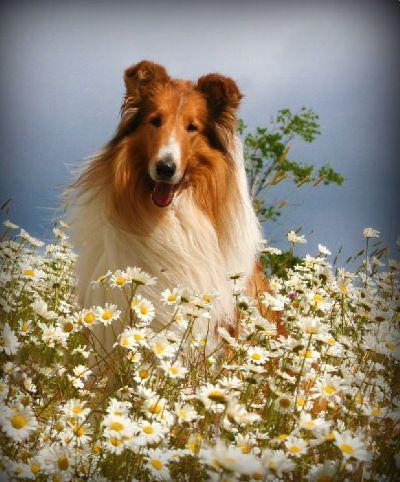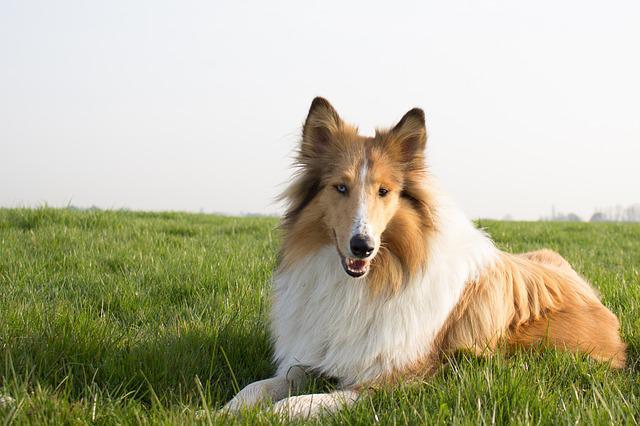The first image is the image on the left, the second image is the image on the right. For the images displayed, is the sentence "There are three dogs outside." factually correct? Answer yes or no. No. 